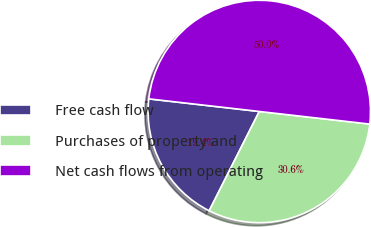Convert chart. <chart><loc_0><loc_0><loc_500><loc_500><pie_chart><fcel>Free cash flow<fcel>Purchases of property and<fcel>Net cash flows from operating<nl><fcel>19.37%<fcel>30.63%<fcel>50.0%<nl></chart> 